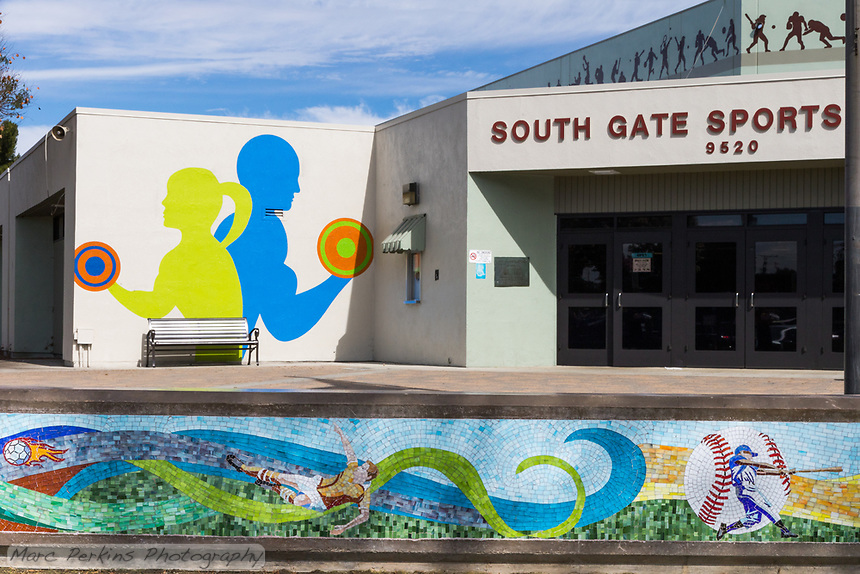How might the surrounding community influence the types of events hosted at this sports center? The surrounding community likely plays a critical role in shaping the events at the sports center. If the community consists of a young, active population, for instance, there might be a higher frequency of competitive sports tournaments or youth-focused activities. Conversely, if there are significant numbers of families or older residents, the center might host more inclusive, community-oriented events that cater to all ages, like family sports days, senior fitness classes, or recreational leagues for casual play. What can you tell about the potential demographic or visitor profile based on the exterior design of the building? The building's modern and inviting exterior, complemented by vibrant murals and an easily accessible layout, suggests it aims to attract a broad cross-section of the local population. This inclusive design indicates that the facility is likely geared towards catering to families, young athletes, and fitness enthusiasts who value both aesthetic appeal and functionality in a sports venue. 